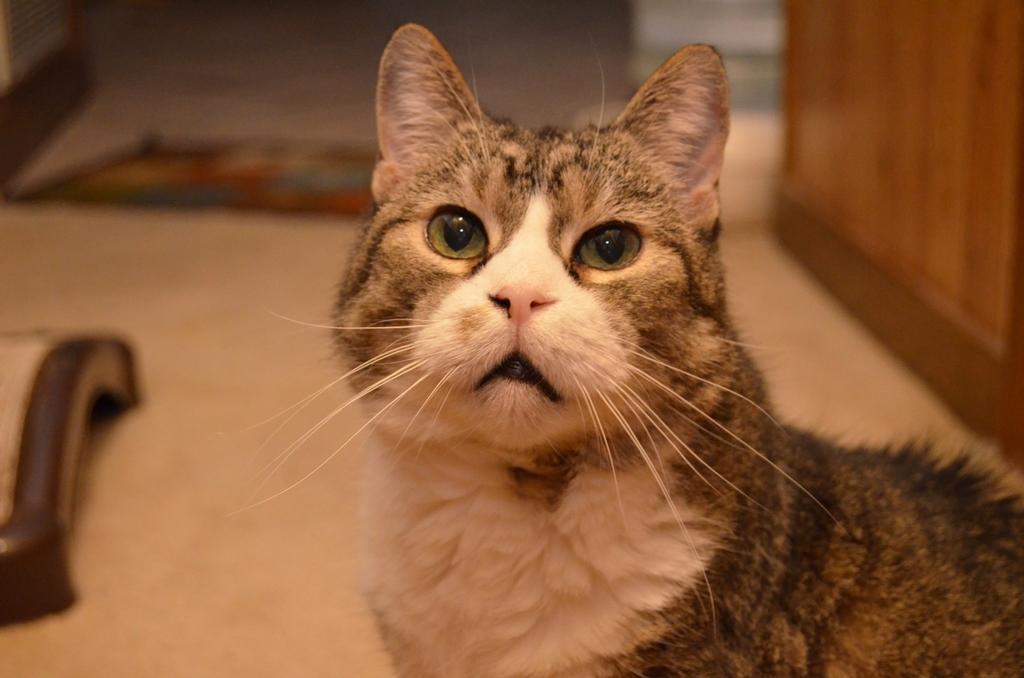Could you give a brief overview of what you see in this image? In the picture I can see a cat is standing on the floor. The background of the image is blurred. 